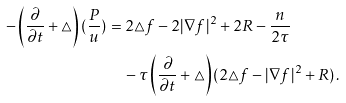Convert formula to latex. <formula><loc_0><loc_0><loc_500><loc_500>- \left ( \frac { \partial } { \partial t } + \triangle \right ) ( \frac { P } { u } ) & = 2 \triangle f - 2 | \nabla f | ^ { 2 } + 2 R - \frac { n } { 2 \tau } \\ & \quad - \tau \left ( \frac { \partial } { \partial t } + \triangle \right ) ( 2 \triangle f - | \nabla f | ^ { 2 } + R ) \, .</formula> 